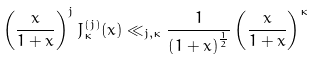<formula> <loc_0><loc_0><loc_500><loc_500>\left ( \frac { x } { 1 + x } \right ) ^ { j } J _ { \kappa } ^ { ( j ) } ( x ) \ll _ { j , \kappa } \frac { 1 } { \left ( 1 + x \right ) ^ { \frac { 1 } { 2 } } } \left ( \frac { x } { 1 + x } \right ) ^ { \kappa }</formula> 